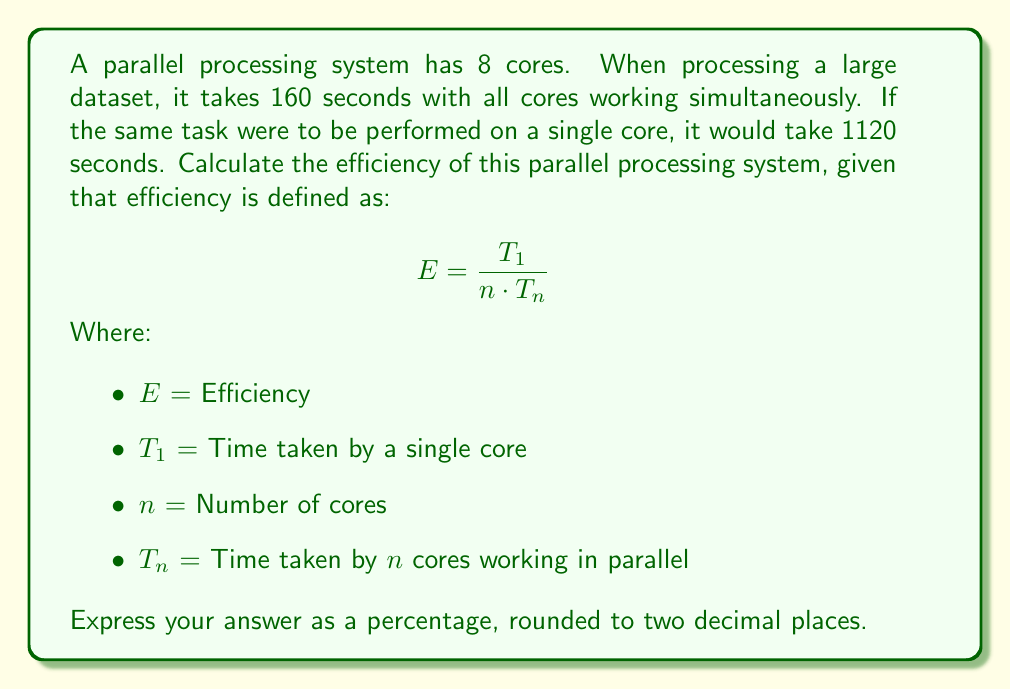Can you answer this question? To solve this problem, we'll follow these steps:

1. Identify the given values:
   $T_1 = 1120$ seconds (time taken by a single core)
   $n = 8$ (number of cores)
   $T_n = 160$ seconds (time taken by all cores working in parallel)

2. Substitute these values into the efficiency formula:

   $$ E = \frac{T_1}{n \cdot T_n} $$
   
   $$ E = \frac{1120}{8 \cdot 160} $$

3. Simplify the calculation:
   
   $$ E = \frac{1120}{1280} $$

4. Perform the division:
   
   $$ E = 0.875 $$

5. Convert to a percentage by multiplying by 100:
   
   $$ E = 0.875 \times 100 = 87.5\% $$

6. Round to two decimal places:
   
   $$ E \approx 87.50\% $$

The efficiency of 87.50% indicates that the parallel processing system is utilizing its cores quite effectively, but there's still some overhead or inefficiency preventing it from achieving 100% efficiency.
Answer: 87.50% 